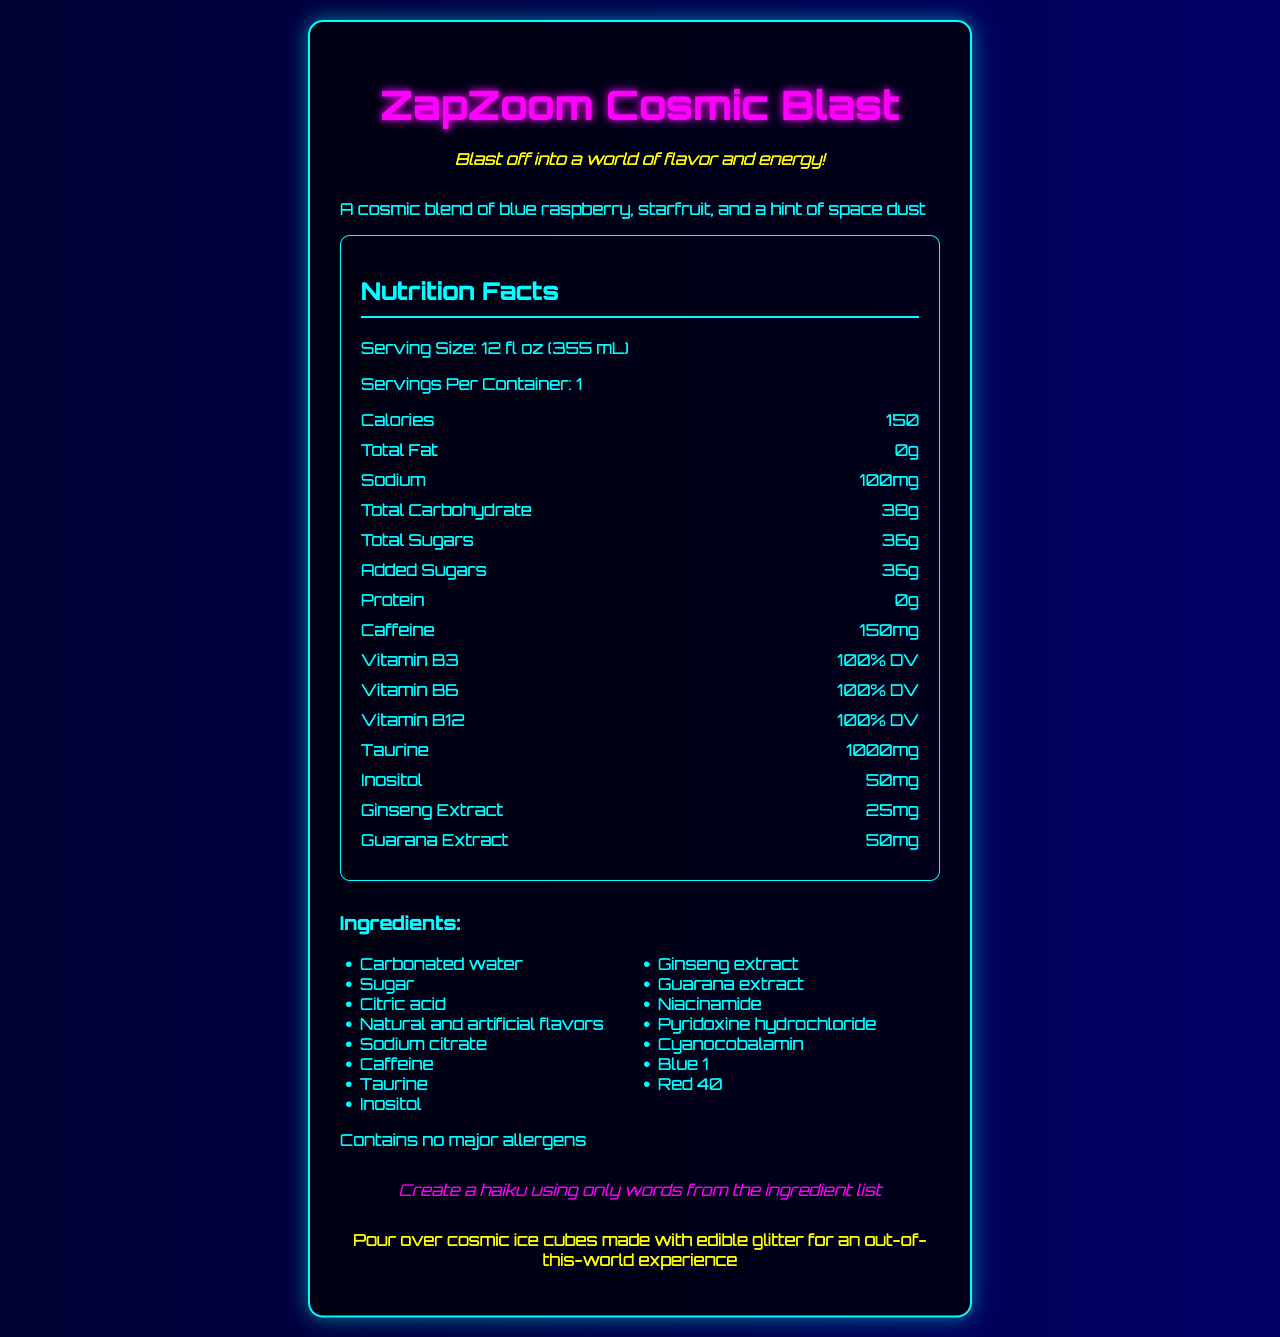what is the serving size of ZapZoom Cosmic Blast? The serving size is mentioned directly under the heading "Nutrition Facts" in the document.
Answer: 12 fl oz (355 mL) How many calories are there per serving? The number of calories per serving is listed in the "Nutrition Facts" section.
Answer: 150 What is the total amount of sugars in ZapZoom Cosmic Blast? The total sugars amount is provided in the nutrition facts list.
Answer: 36g How much caffeine does each serving contain? The caffeine content per serving is indicated in the nutrition facts section.
Answer: 150mg What percentage of the daily value for Vitamin B12 does this drink provide? The document specifies that the drink provides 100% DV of Vitamin B12.
Answer: 100% DV What are the main flavors in ZapZoom Cosmic Blast? These flavors are mentioned in the "flavor description" segment of the document.
Answer: Blue raspberry, starfruit, and a hint of space dust Does the drink contain any protein? The protein content is listed as 0g in the nutrition facts.
Answer: No Which of the following vitamins are included at 100% DV in ZapZoom Cosmic Blast? A. Vitamin B3, Vitamin B6, Vitamin C B. Vitamin B3, Vitamin B12, Vitamin D C. Vitamin B3, Vitamin B6, Vitamin B12 The document states that Vitamin B3, B6, and B12 each have a daily value of 100%.
Answer: C What is the sodium content per serving? A. 50mg B. 100mg C. 200mg D. 150mg The sodium content per serving is listed as 100mg in the nutrition facts.
Answer: B Verdict whether ZapZoom Cosmic Blast is a major allergen? The document clearly states it contains no major allergens.
Answer: No Describe the main idea of the document. The detailed description in the document includes nutrition facts, flavor profile, ingredients, allergen information, a serving suggestion, and a word play challenge related to the product.
Answer: The document provides detailed nutrition facts, flavor descriptions, and marketing information for ZapZoom Cosmic Blast, an energy drink with a unique blend of flavors and no major allergens. It highlights the drink's vitamins, caffeine content, and creative serving suggestions. What are the creative elements included in the product description? The document includes a cosmic-themed flavor description, a marketing tagline encouraging energy, a haiku challenge using ingredient words, and a serving suggestion involving glitter ice cubes.
Answer: Flavor description, marketing tagline, word play challenge, creative serving suggestion What is the total carbohydrate content in the ZapZoom Cosmic Blast? The document specifies the total carbohydrates under the nutrition facts.
Answer: 38g How much ginseng extract does the drink contain? The document lists ginseng extract in the nutrition facts section.
Answer: 25mg What is the main function of taurine in energy drinks? The document lists taurine and its quantity but does not provide further details on its function or benefits.
Answer: Not enough information 